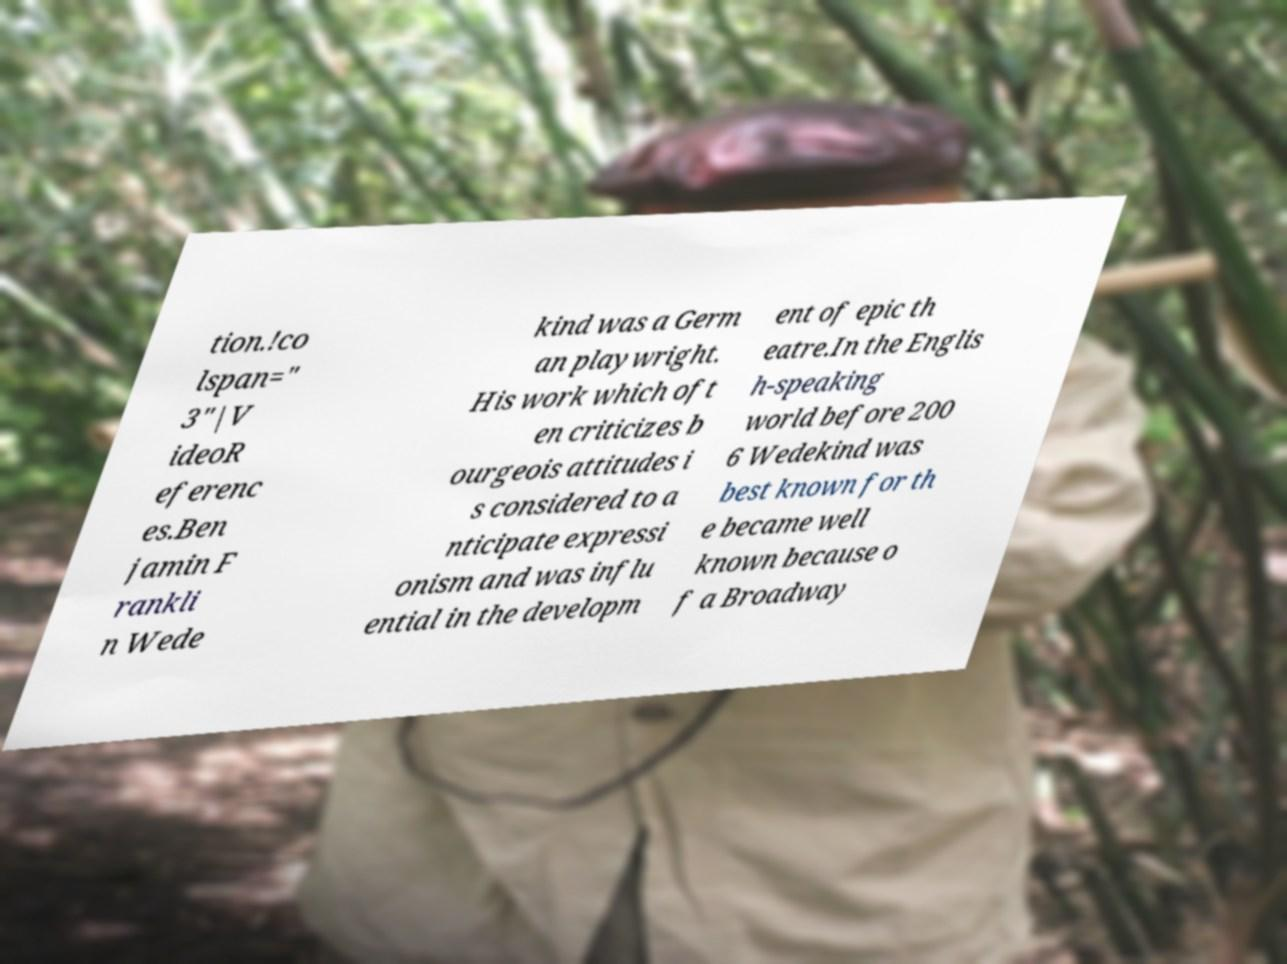There's text embedded in this image that I need extracted. Can you transcribe it verbatim? tion.!co lspan=" 3"|V ideoR eferenc es.Ben jamin F rankli n Wede kind was a Germ an playwright. His work which oft en criticizes b ourgeois attitudes i s considered to a nticipate expressi onism and was influ ential in the developm ent of epic th eatre.In the Englis h-speaking world before 200 6 Wedekind was best known for th e became well known because o f a Broadway 